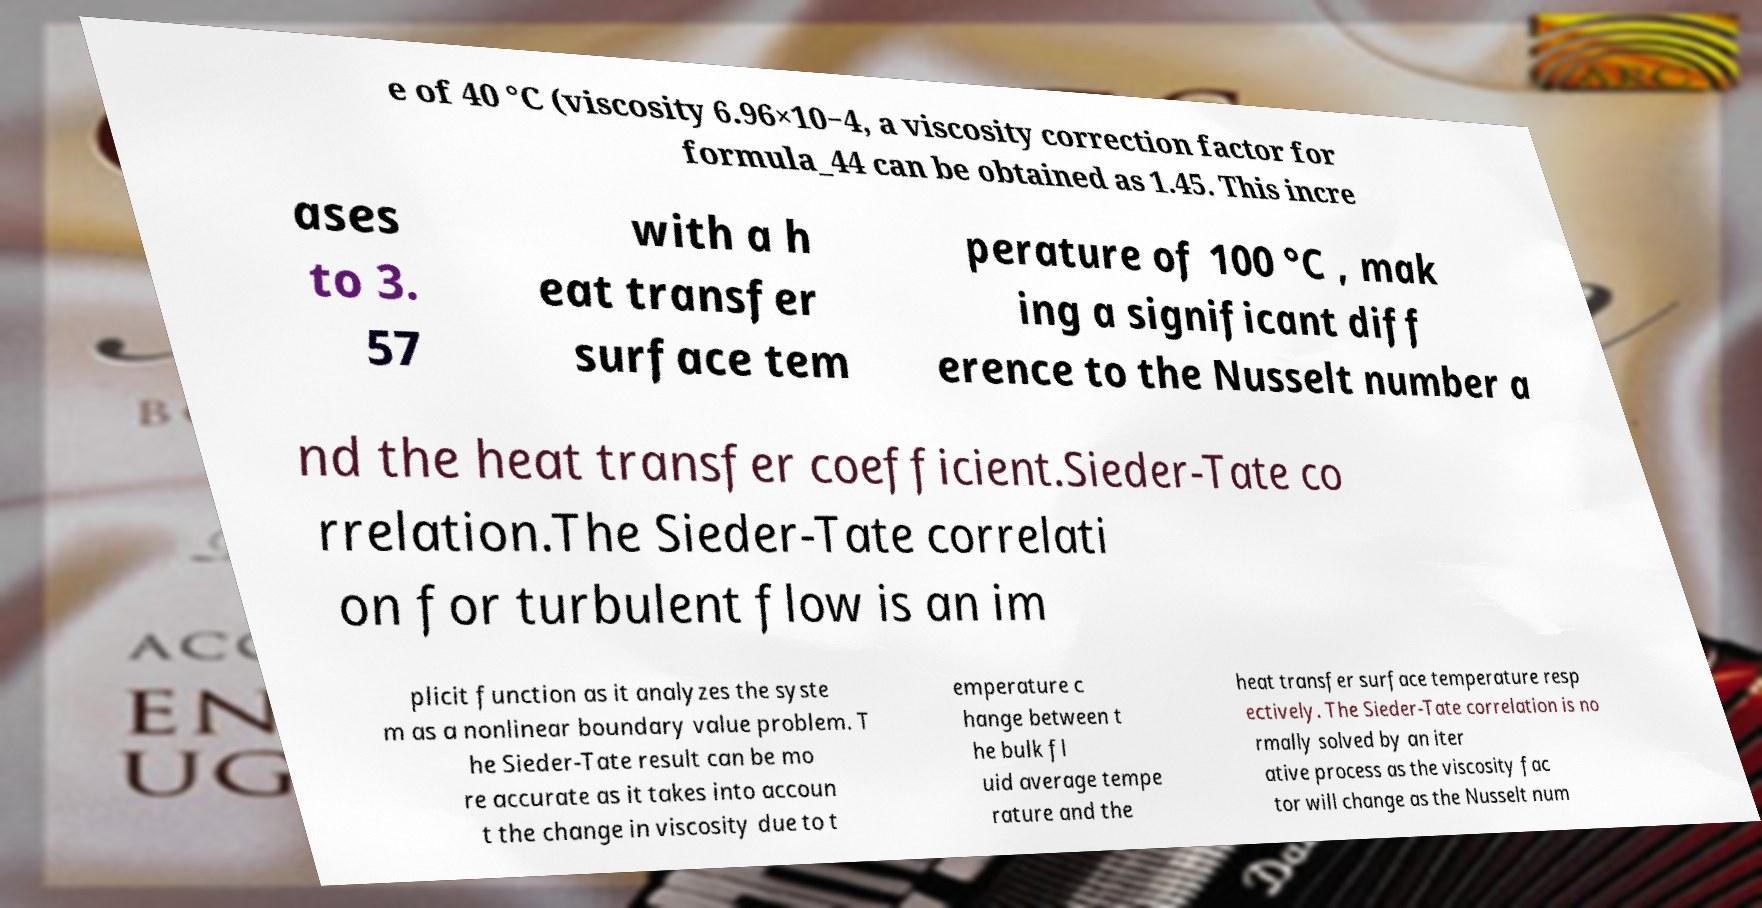Could you assist in decoding the text presented in this image and type it out clearly? e of 40 °C (viscosity 6.96×10−4, a viscosity correction factor for formula_44 can be obtained as 1.45. This incre ases to 3. 57 with a h eat transfer surface tem perature of 100 °C , mak ing a significant diff erence to the Nusselt number a nd the heat transfer coefficient.Sieder-Tate co rrelation.The Sieder-Tate correlati on for turbulent flow is an im plicit function as it analyzes the syste m as a nonlinear boundary value problem. T he Sieder-Tate result can be mo re accurate as it takes into accoun t the change in viscosity due to t emperature c hange between t he bulk fl uid average tempe rature and the heat transfer surface temperature resp ectively. The Sieder-Tate correlation is no rmally solved by an iter ative process as the viscosity fac tor will change as the Nusselt num 